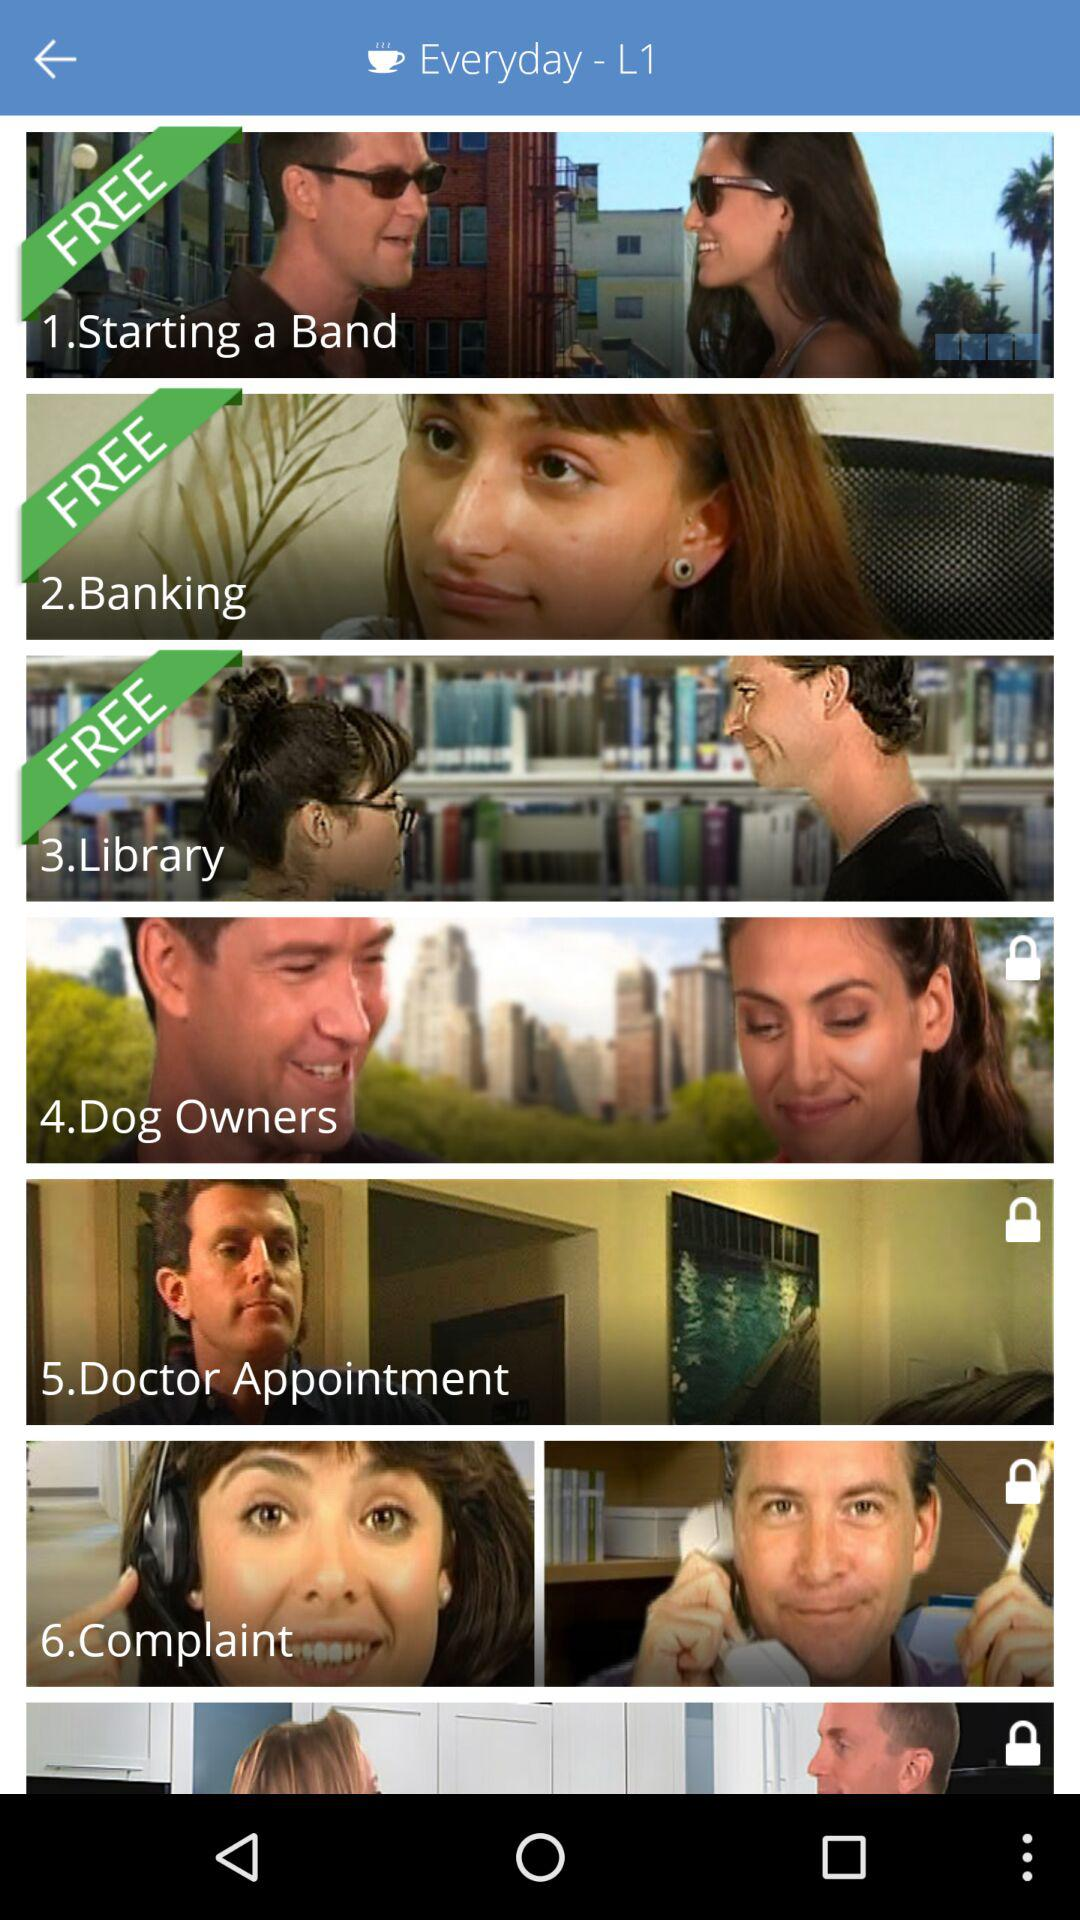What are the names of the locked topics? The names of the locked topics are "Dog Owners", "Doctor Appointment" and "Complaint". 